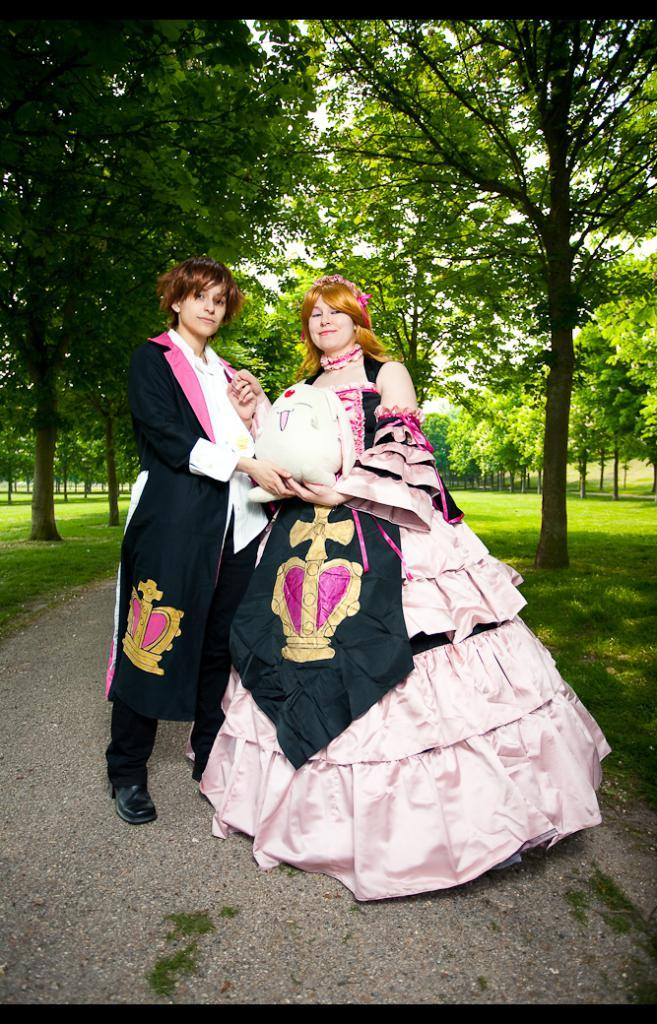How many people are present in the image? There are two people standing in the image. What are the people holding in the image? The people are holding something, but the specific object is not mentioned in the facts. What can be seen in the background of the image? There are trees in the background of the image. What is the color of the trees in the image? The trees are green in color. What language is the zebra speaking in the image? There is no zebra present in the image, so it is not possible to determine what language it might be speaking. 